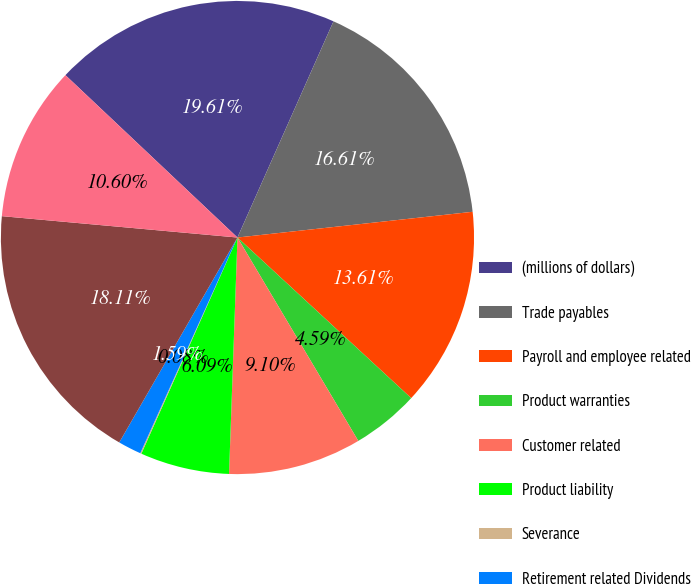<chart> <loc_0><loc_0><loc_500><loc_500><pie_chart><fcel>(millions of dollars)<fcel>Trade payables<fcel>Payroll and employee related<fcel>Product warranties<fcel>Customer related<fcel>Product liability<fcel>Severance<fcel>Retirement related Dividends<fcel>Other Total accounts payable<fcel>Deferred income taxes<nl><fcel>19.61%<fcel>16.61%<fcel>13.61%<fcel>4.59%<fcel>9.1%<fcel>6.09%<fcel>0.08%<fcel>1.59%<fcel>18.11%<fcel>10.6%<nl></chart> 